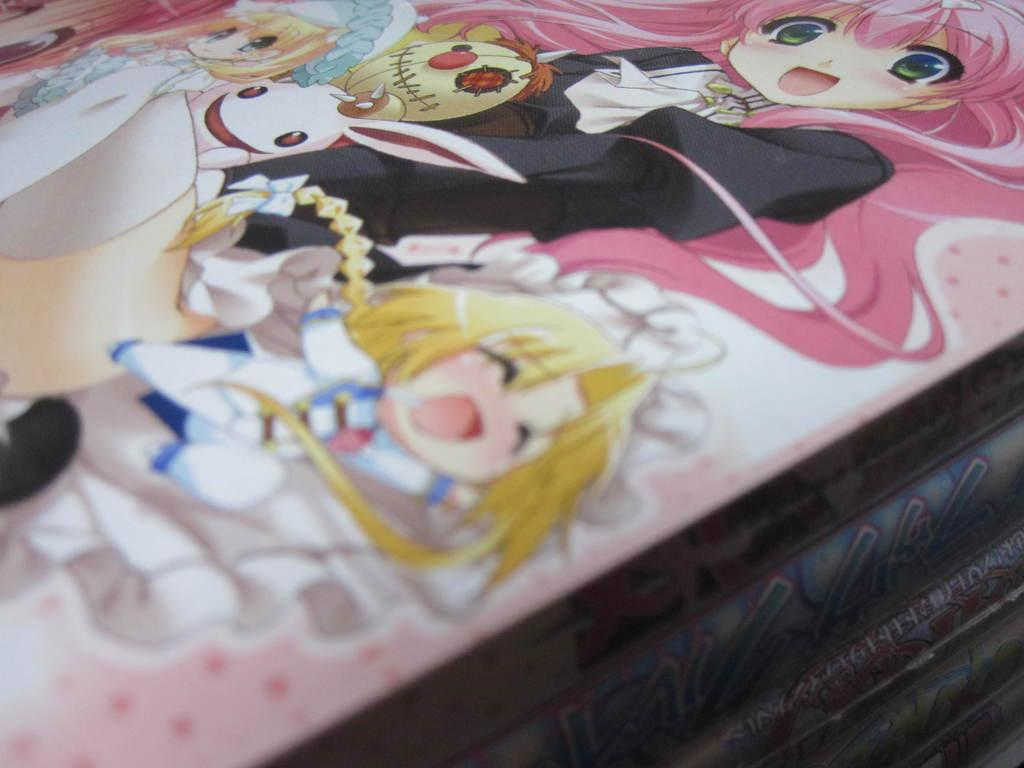What type of objects can be seen in the image? There are books in the image. Can you describe any additional features of the books? Yes, there is some art on the books. What type of tank is visible in the image? There is no tank present in the image; it features books with art on them. What game is being played in the image? There is no game being played in the image; it features books with art on them. 